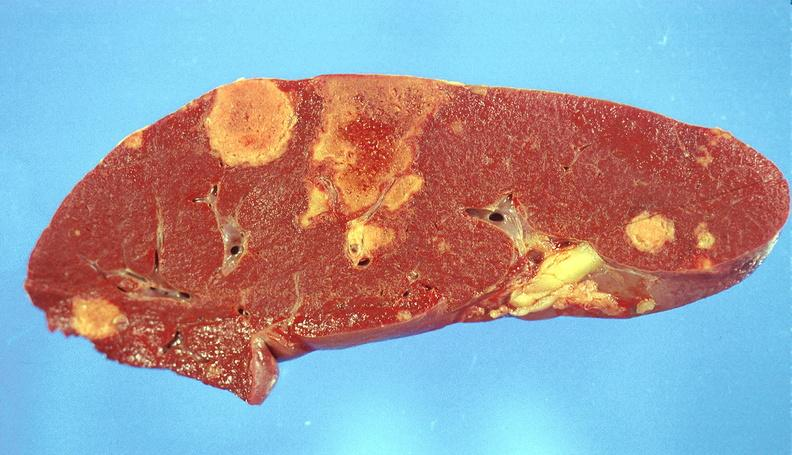does hypertrophic gastritis show splenic infarcts?
Answer the question using a single word or phrase. No 